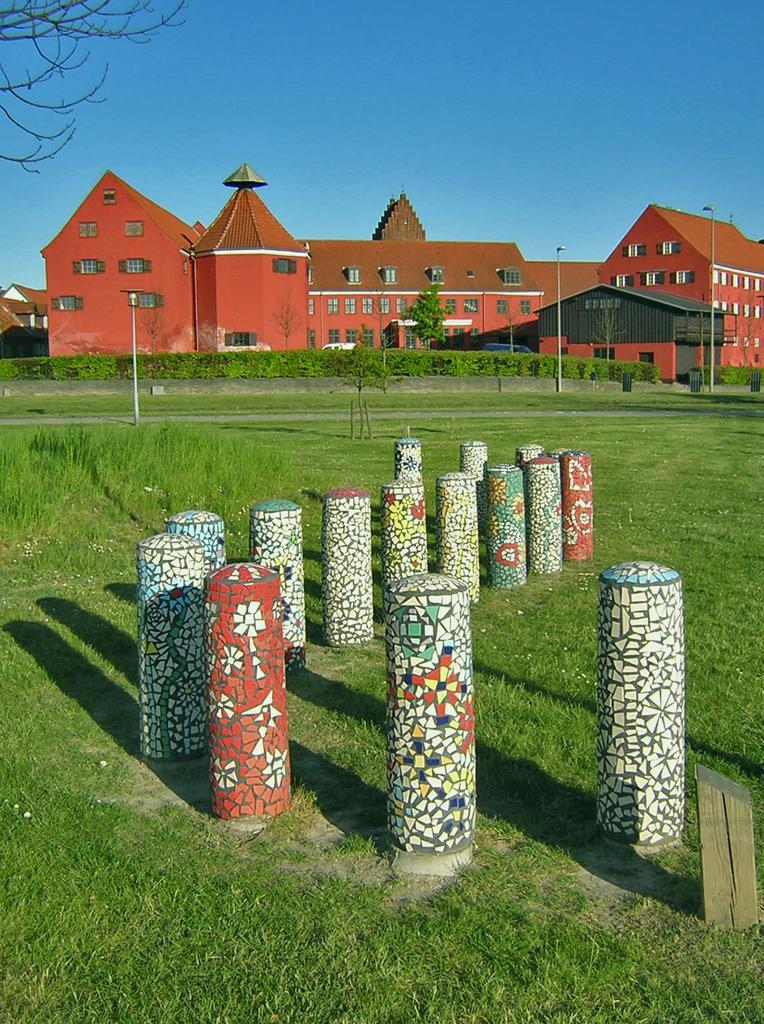What type of structures can be seen in the image? There are buildings in the image. What type of lighting is present in the image? There are street lights in the image. What type of vegetation is present in the image? Garden plants and a tree are present in the image. What type of ground surface is visible in the image? Grass is visible in the image. What type of vertical object is present in the image? There is a pole in the image. What color can be observed in the image? There are black color objects in the image. What part of the natural environment is visible in the image? The sky is visible in the image. What type of news can be seen on the pole in the image? There is no news present in the image; the pole is a vertical object without any text or information. Where is the cellar located in the image? There is no cellar present in the image; the image only shows outdoor elements such as buildings, street lights, garden plants, grass, a tree, a pole, and the sky. 